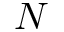<formula> <loc_0><loc_0><loc_500><loc_500>N</formula> 